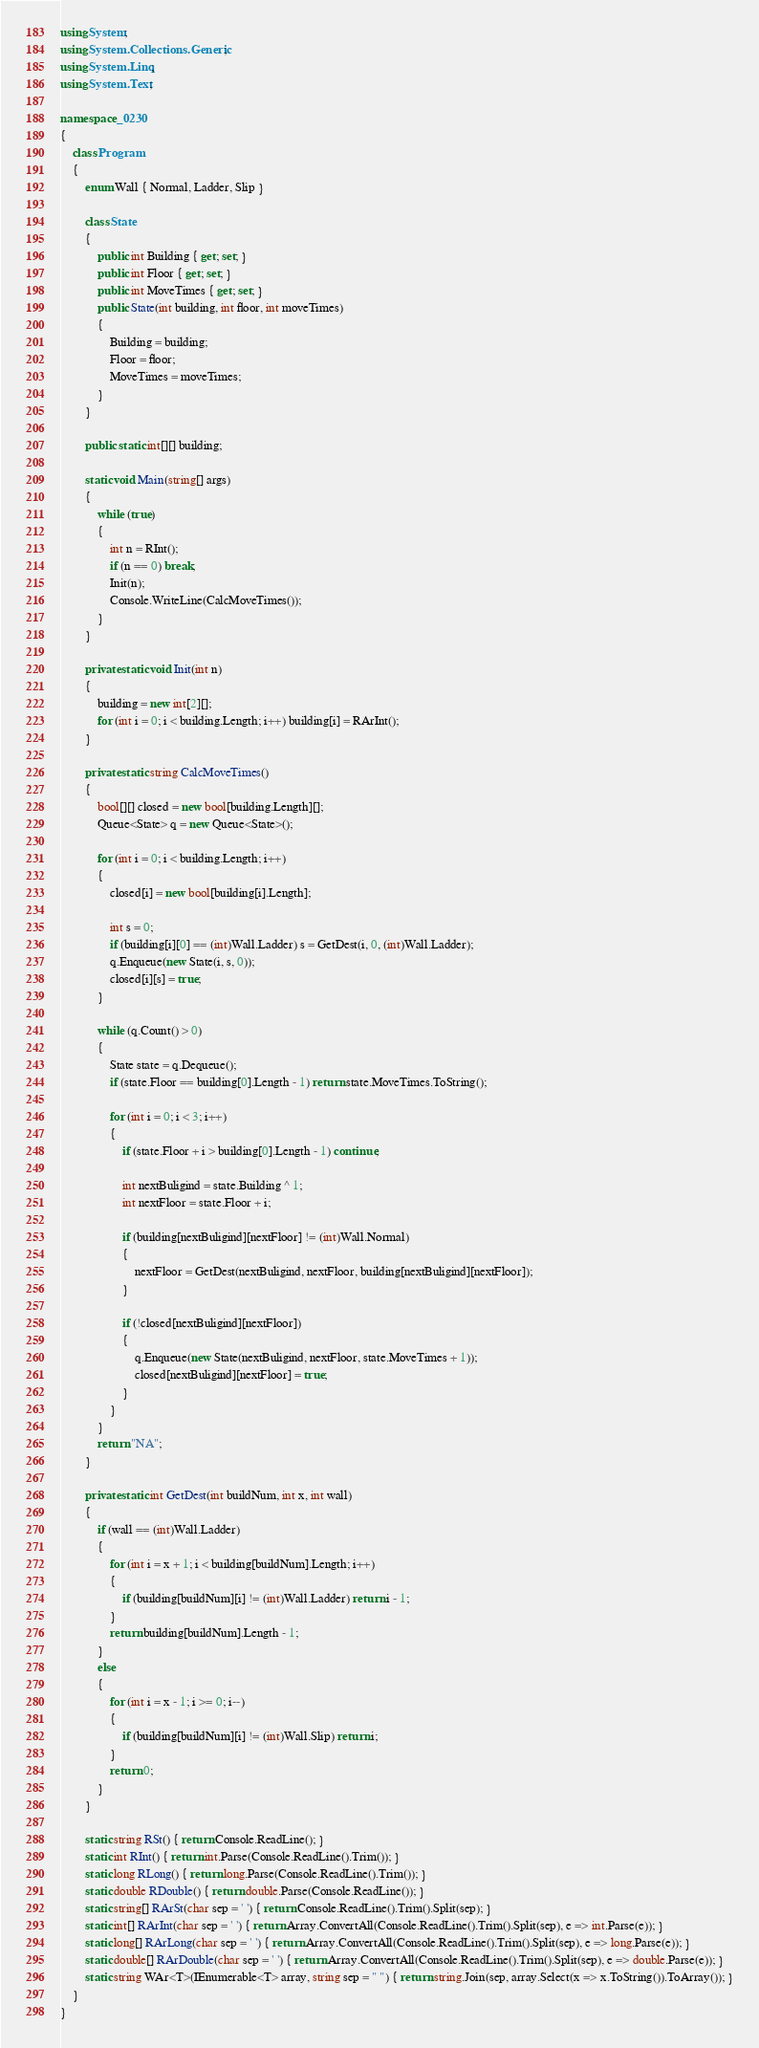Convert code to text. <code><loc_0><loc_0><loc_500><loc_500><_C#_>using System;
using System.Collections.Generic;
using System.Linq;
using System.Text;

namespace _0230
{
    class Program
    {
        enum Wall { Normal, Ladder, Slip }

        class State
        {
            public int Building { get; set; }
            public int Floor { get; set; }
            public int MoveTimes { get; set; }
            public State(int building, int floor, int moveTimes)
            {
                Building = building;
                Floor = floor;
                MoveTimes = moveTimes;
            }
        }

        public static int[][] building;

        static void Main(string[] args)
        {
            while (true)
            {
                int n = RInt();
                if (n == 0) break;
                Init(n);
                Console.WriteLine(CalcMoveTimes());
            }
        }

        private static void Init(int n)
        {
            building = new int[2][];
            for (int i = 0; i < building.Length; i++) building[i] = RArInt();
        }

        private static string CalcMoveTimes()
        {
            bool[][] closed = new bool[building.Length][];
            Queue<State> q = new Queue<State>();

            for (int i = 0; i < building.Length; i++)
            {
                closed[i] = new bool[building[i].Length];

                int s = 0;
                if (building[i][0] == (int)Wall.Ladder) s = GetDest(i, 0, (int)Wall.Ladder);       
                q.Enqueue(new State(i, s, 0));
                closed[i][s] = true;
            }

            while (q.Count() > 0)
            {
                State state = q.Dequeue();
                if (state.Floor == building[0].Length - 1) return state.MoveTimes.ToString();

                for (int i = 0; i < 3; i++)
                {
                    if (state.Floor + i > building[0].Length - 1) continue;

                    int nextBuligind = state.Building ^ 1;
                    int nextFloor = state.Floor + i;

                    if (building[nextBuligind][nextFloor] != (int)Wall.Normal)
                    {
                        nextFloor = GetDest(nextBuligind, nextFloor, building[nextBuligind][nextFloor]);
                    }

                    if (!closed[nextBuligind][nextFloor])
                    {
                        q.Enqueue(new State(nextBuligind, nextFloor, state.MoveTimes + 1));
                        closed[nextBuligind][nextFloor] = true;
                    }
                }
            }
            return "NA";
        }

        private static int GetDest(int buildNum, int x, int wall)
        {
            if (wall == (int)Wall.Ladder)
            {
                for (int i = x + 1; i < building[buildNum].Length; i++)
                {
                    if (building[buildNum][i] != (int)Wall.Ladder) return i - 1;
                }
                return building[buildNum].Length - 1;
            }
            else
            {
                for (int i = x - 1; i >= 0; i--)
                {
                    if (building[buildNum][i] != (int)Wall.Slip) return i;
                }
                return 0;
            }
        }

        static string RSt() { return Console.ReadLine(); }
        static int RInt() { return int.Parse(Console.ReadLine().Trim()); }
        static long RLong() { return long.Parse(Console.ReadLine().Trim()); }
        static double RDouble() { return double.Parse(Console.ReadLine()); }
        static string[] RArSt(char sep = ' ') { return Console.ReadLine().Trim().Split(sep); }
        static int[] RArInt(char sep = ' ') { return Array.ConvertAll(Console.ReadLine().Trim().Split(sep), e => int.Parse(e)); }
        static long[] RArLong(char sep = ' ') { return Array.ConvertAll(Console.ReadLine().Trim().Split(sep), e => long.Parse(e)); }
        static double[] RArDouble(char sep = ' ') { return Array.ConvertAll(Console.ReadLine().Trim().Split(sep), e => double.Parse(e)); }
        static string WAr<T>(IEnumerable<T> array, string sep = " ") { return string.Join(sep, array.Select(x => x.ToString()).ToArray()); }
    }
}

</code> 